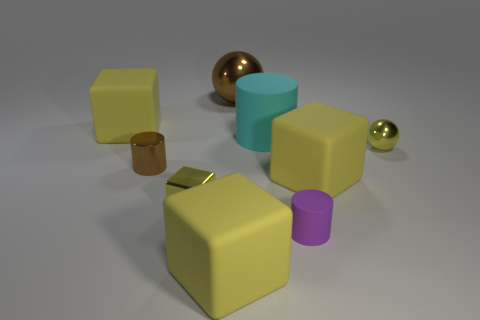Subtract all small yellow blocks. How many blocks are left? 3 Add 1 small green matte cylinders. How many objects exist? 10 Subtract all tiny red cubes. Subtract all tiny brown cylinders. How many objects are left? 8 Add 2 large yellow objects. How many large yellow objects are left? 5 Add 2 brown metal objects. How many brown metal objects exist? 4 Subtract 0 gray spheres. How many objects are left? 9 Subtract all spheres. How many objects are left? 7 Subtract all green cylinders. Subtract all gray balls. How many cylinders are left? 3 